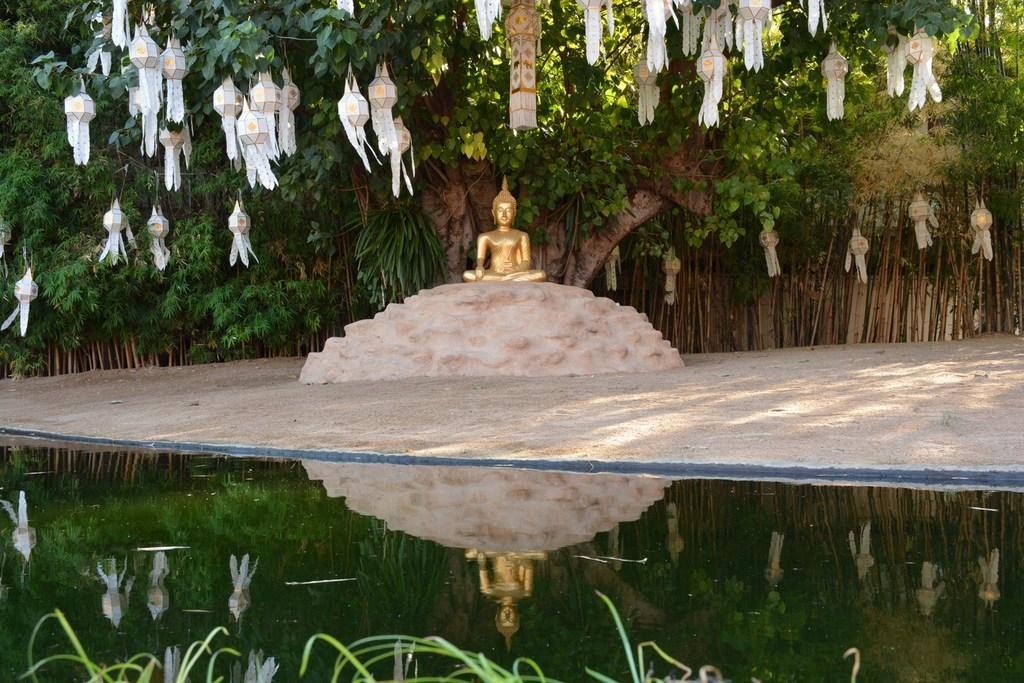In one or two sentences, can you explain what this image depicts? In this picture we can see water, statue, lamps and in the background we can see trees. 